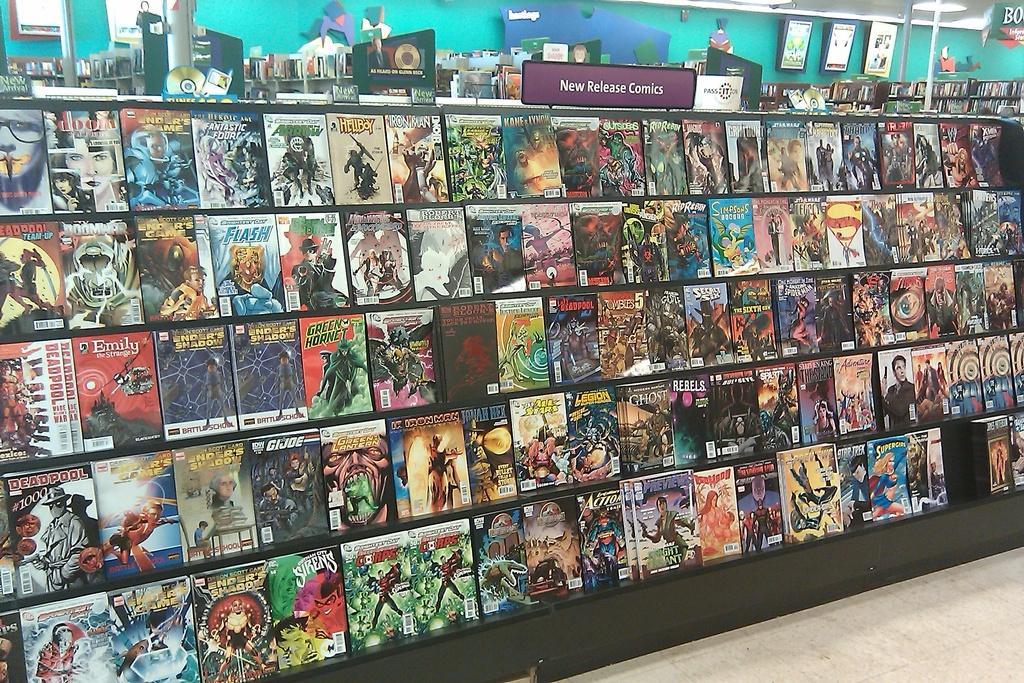Could you give a brief overview of what you see in this image? In the center of the image we can see a rack contains books and some objects, boards. At the top of the image we can see wall, roof, light. At the bottom right corner there is a floor. 